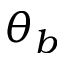Convert formula to latex. <formula><loc_0><loc_0><loc_500><loc_500>\theta _ { b }</formula> 